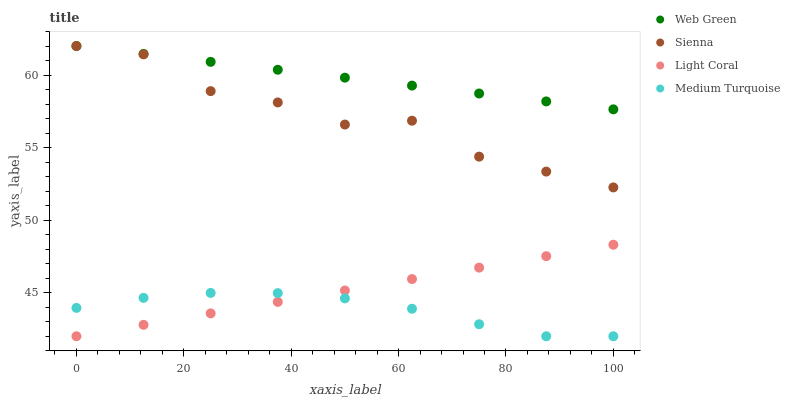Does Medium Turquoise have the minimum area under the curve?
Answer yes or no. Yes. Does Web Green have the maximum area under the curve?
Answer yes or no. Yes. Does Light Coral have the minimum area under the curve?
Answer yes or no. No. Does Light Coral have the maximum area under the curve?
Answer yes or no. No. Is Light Coral the smoothest?
Answer yes or no. Yes. Is Sienna the roughest?
Answer yes or no. Yes. Is Medium Turquoise the smoothest?
Answer yes or no. No. Is Medium Turquoise the roughest?
Answer yes or no. No. Does Light Coral have the lowest value?
Answer yes or no. Yes. Does Web Green have the lowest value?
Answer yes or no. No. Does Web Green have the highest value?
Answer yes or no. Yes. Does Light Coral have the highest value?
Answer yes or no. No. Is Medium Turquoise less than Sienna?
Answer yes or no. Yes. Is Sienna greater than Medium Turquoise?
Answer yes or no. Yes. Does Sienna intersect Web Green?
Answer yes or no. Yes. Is Sienna less than Web Green?
Answer yes or no. No. Is Sienna greater than Web Green?
Answer yes or no. No. Does Medium Turquoise intersect Sienna?
Answer yes or no. No. 